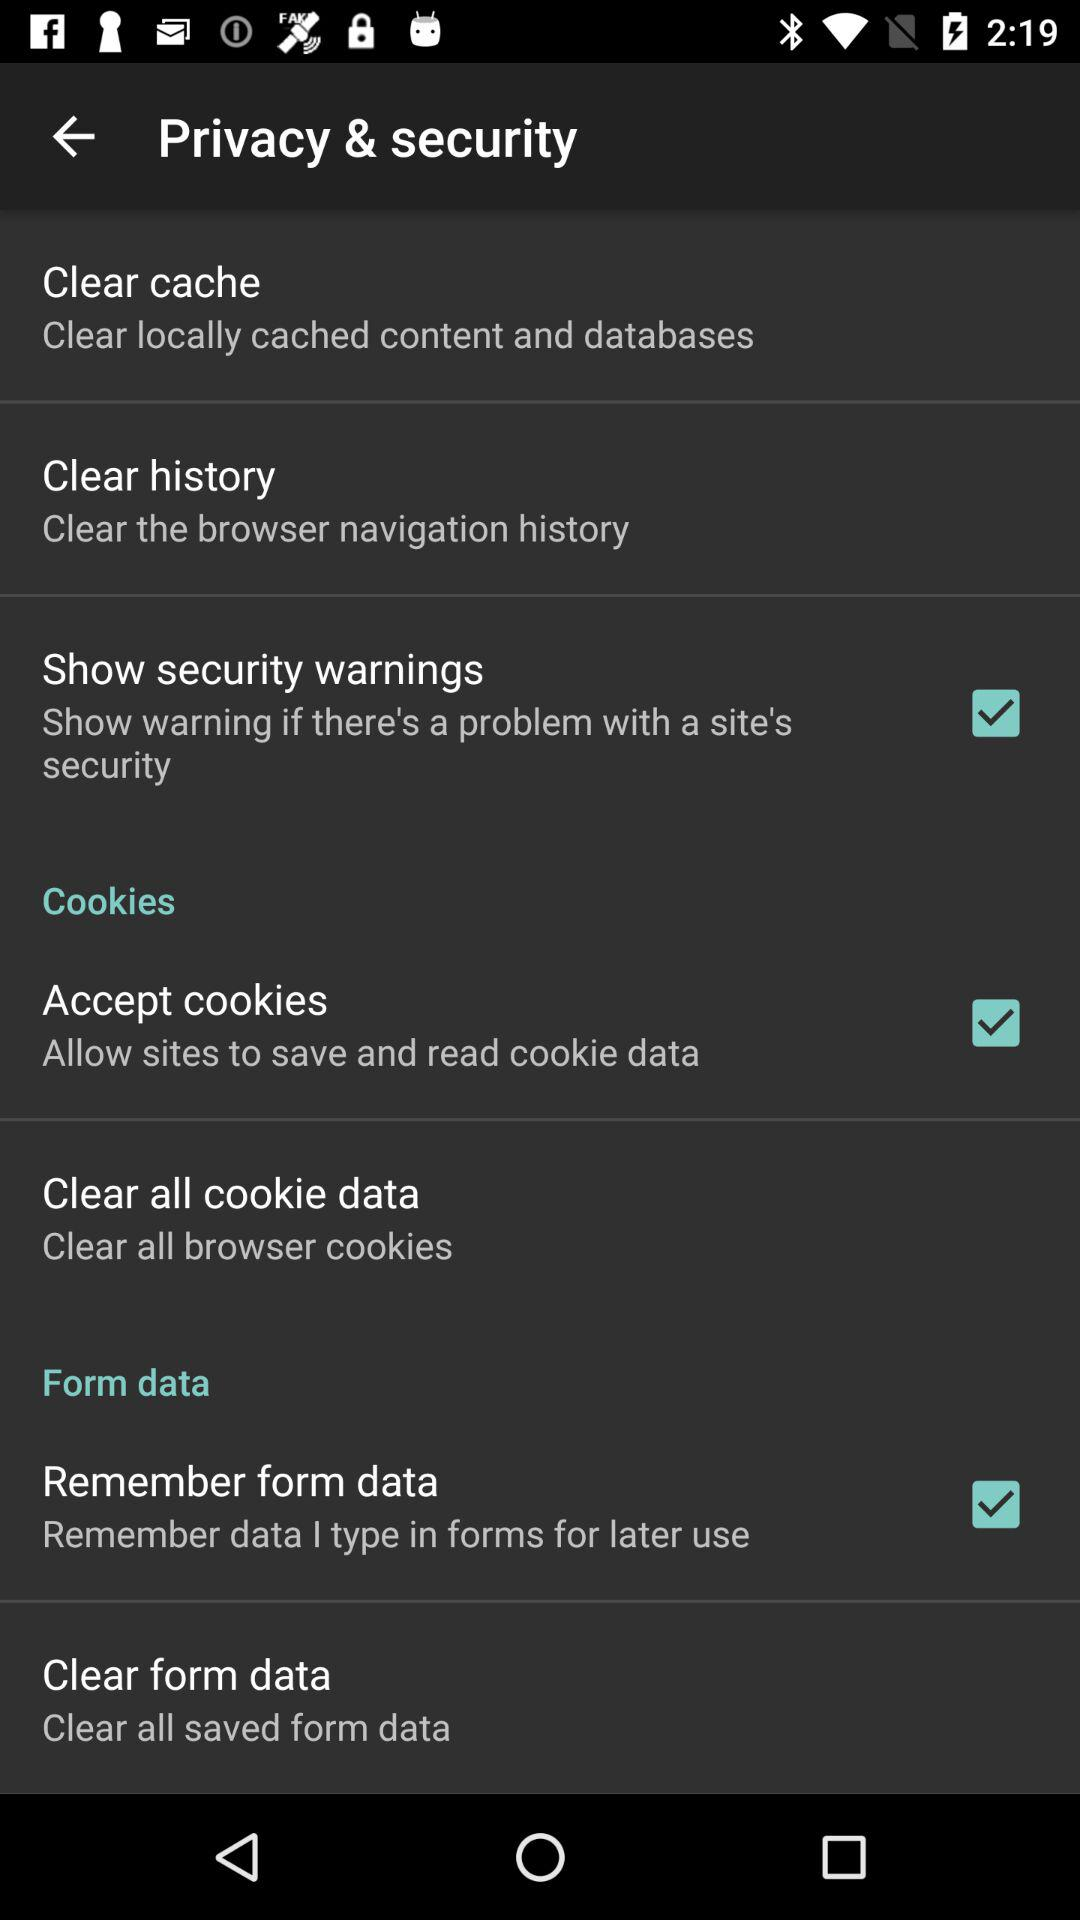What does clearing all form data involve? Clearing all form data will delete any information you've previously entered into forms on websites, such as your name, address, or credit card number. This is often used to protect your personal information from being accessed by others who might use your device or to keep your data private when using shared or public computers. 